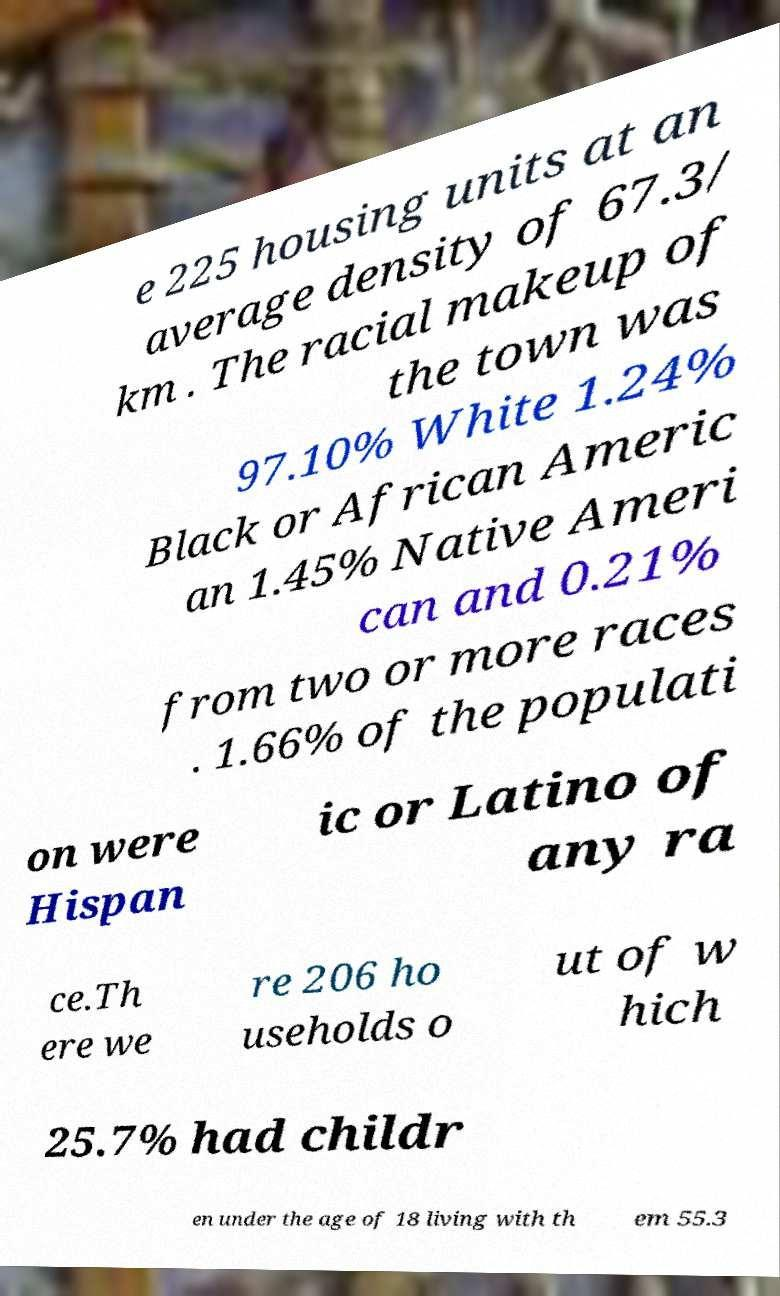For documentation purposes, I need the text within this image transcribed. Could you provide that? e 225 housing units at an average density of 67.3/ km . The racial makeup of the town was 97.10% White 1.24% Black or African Americ an 1.45% Native Ameri can and 0.21% from two or more races . 1.66% of the populati on were Hispan ic or Latino of any ra ce.Th ere we re 206 ho useholds o ut of w hich 25.7% had childr en under the age of 18 living with th em 55.3 